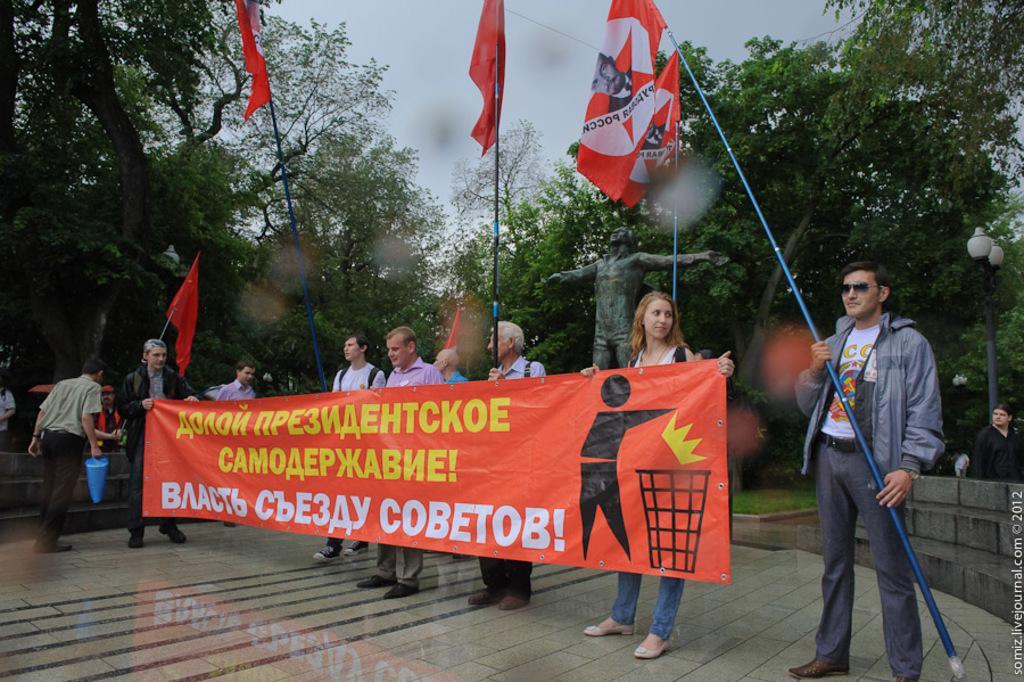In one or two sentences, can you explain what this image depicts? There are people holding a poster and flags in the foreground area of the image, there are stairs, people, pole, statue, trees and the sky in the background. 